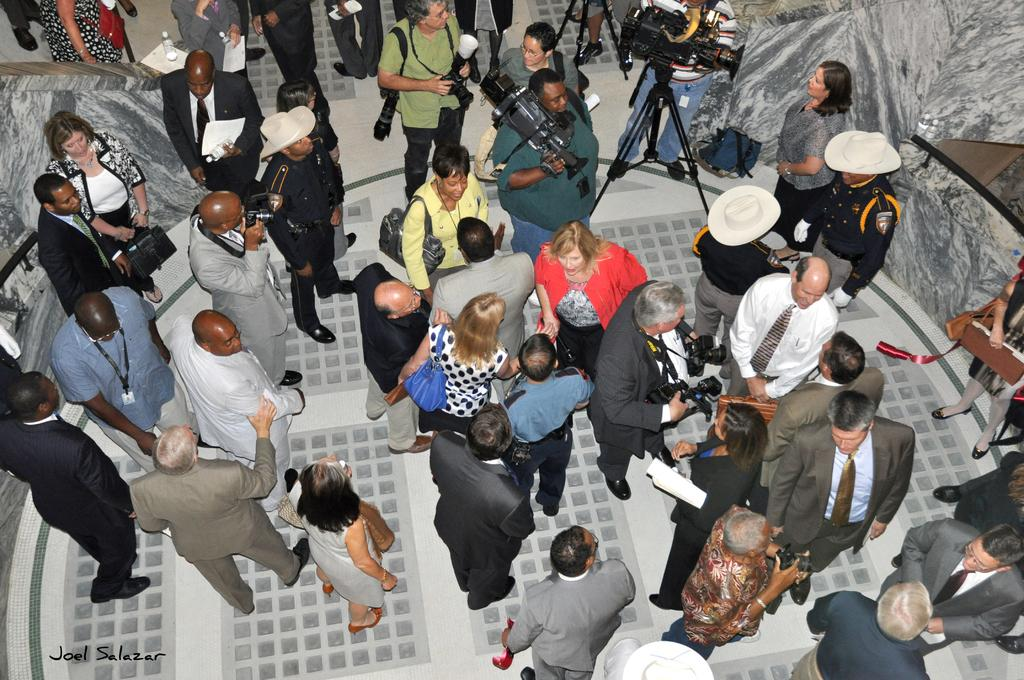How many people are present in the image? There are many people in the image. What are some people doing in the image? Some people are on the floor, holding cameras, and holding papers. What else can be seen in the image besides people? There are objects visible in the image. What type of bone is being used as a prop in the image? There is no bone present in the image. What kind of business is being conducted in the image? The image does not depict any business activities. 